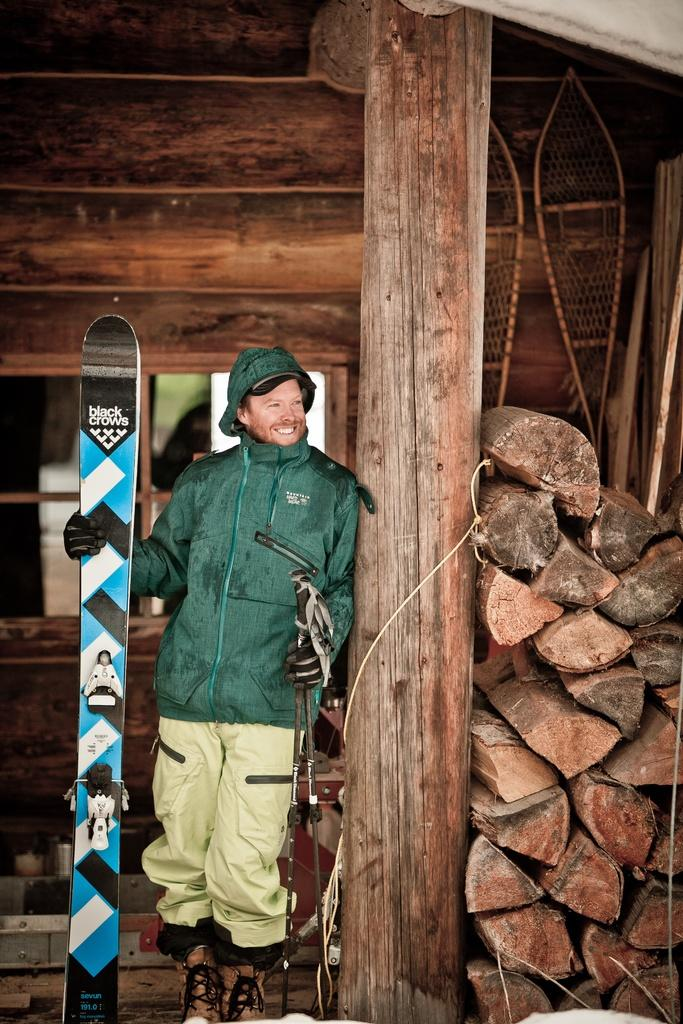What is the main subject of the image? There is a man in the image. What is the man doing in the image? The man is standing in the image. What equipment is the man holding in the image? The man is holding skis and ski sticks in the image. What can be seen on the right side of the image? There are tree trunks on the right side of the image. What type of sweater is the man wearing in the image? The provided facts do not mention any clothing, including a sweater, that the man is wearing in the image. What punishment is the man receiving for his actions in the image? There is no indication of any punishment or wrongdoing in the image; the man is simply holding skis and ski sticks. 